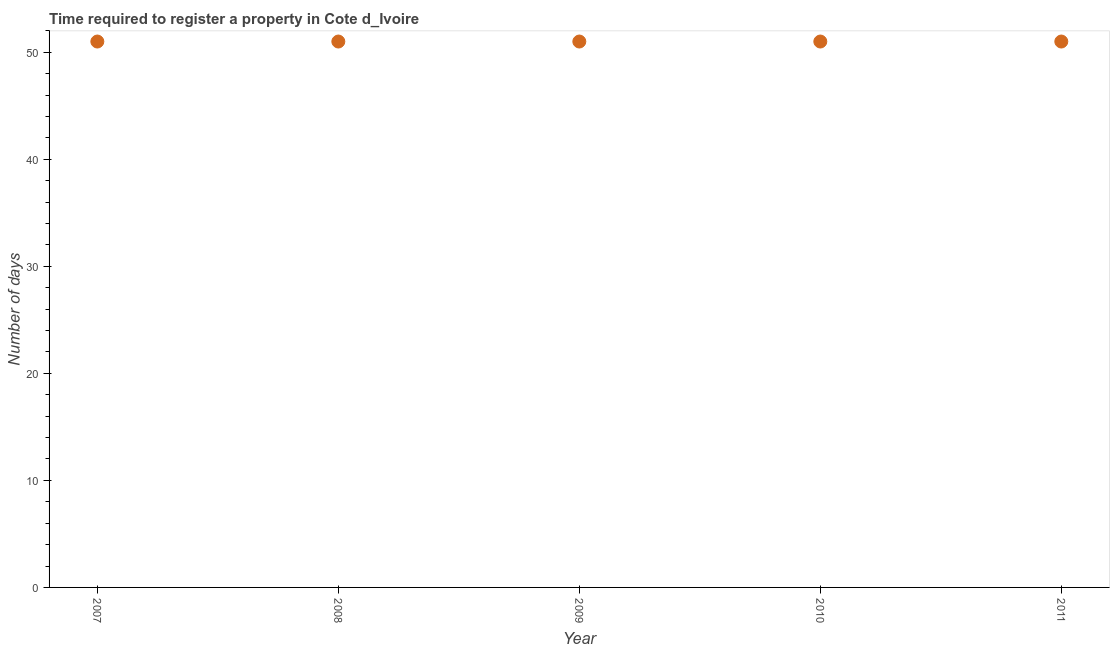What is the number of days required to register property in 2010?
Offer a very short reply. 51. Across all years, what is the maximum number of days required to register property?
Provide a succinct answer. 51. Across all years, what is the minimum number of days required to register property?
Give a very brief answer. 51. In which year was the number of days required to register property maximum?
Ensure brevity in your answer.  2007. In which year was the number of days required to register property minimum?
Provide a short and direct response. 2007. What is the sum of the number of days required to register property?
Provide a short and direct response. 255. What is the difference between the number of days required to register property in 2009 and 2011?
Offer a very short reply. 0. What is the average number of days required to register property per year?
Provide a short and direct response. 51. What is the median number of days required to register property?
Make the answer very short. 51. Do a majority of the years between 2007 and 2008 (inclusive) have number of days required to register property greater than 26 days?
Keep it short and to the point. Yes. What is the ratio of the number of days required to register property in 2009 to that in 2010?
Make the answer very short. 1. Is the number of days required to register property in 2009 less than that in 2010?
Provide a short and direct response. No. Is the difference between the number of days required to register property in 2007 and 2010 greater than the difference between any two years?
Give a very brief answer. Yes. In how many years, is the number of days required to register property greater than the average number of days required to register property taken over all years?
Keep it short and to the point. 0. Does the number of days required to register property monotonically increase over the years?
Ensure brevity in your answer.  No. How many dotlines are there?
Your answer should be compact. 1. How many years are there in the graph?
Offer a terse response. 5. What is the difference between two consecutive major ticks on the Y-axis?
Offer a very short reply. 10. Are the values on the major ticks of Y-axis written in scientific E-notation?
Give a very brief answer. No. What is the title of the graph?
Offer a terse response. Time required to register a property in Cote d_Ivoire. What is the label or title of the Y-axis?
Give a very brief answer. Number of days. What is the Number of days in 2007?
Your answer should be very brief. 51. What is the Number of days in 2008?
Your answer should be very brief. 51. What is the Number of days in 2009?
Offer a terse response. 51. What is the Number of days in 2011?
Your response must be concise. 51. What is the difference between the Number of days in 2007 and 2009?
Offer a terse response. 0. What is the difference between the Number of days in 2007 and 2011?
Keep it short and to the point. 0. What is the difference between the Number of days in 2008 and 2009?
Keep it short and to the point. 0. What is the difference between the Number of days in 2008 and 2011?
Your answer should be very brief. 0. What is the difference between the Number of days in 2009 and 2010?
Make the answer very short. 0. What is the difference between the Number of days in 2009 and 2011?
Provide a short and direct response. 0. What is the difference between the Number of days in 2010 and 2011?
Make the answer very short. 0. What is the ratio of the Number of days in 2008 to that in 2009?
Your answer should be very brief. 1. What is the ratio of the Number of days in 2008 to that in 2010?
Make the answer very short. 1. 